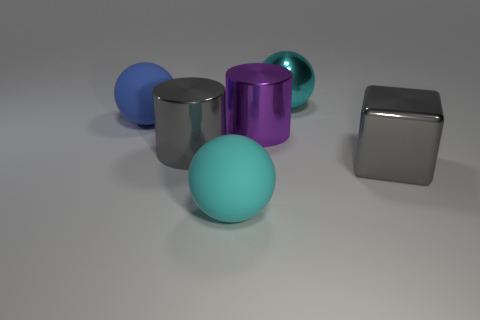Add 2 large spheres. How many objects exist? 8 Subtract all cylinders. How many objects are left? 4 Add 5 large gray metal blocks. How many large gray metal blocks exist? 6 Subtract 0 brown cylinders. How many objects are left? 6 Subtract all large metal balls. Subtract all large metallic cylinders. How many objects are left? 3 Add 4 large purple metal things. How many large purple metal things are left? 5 